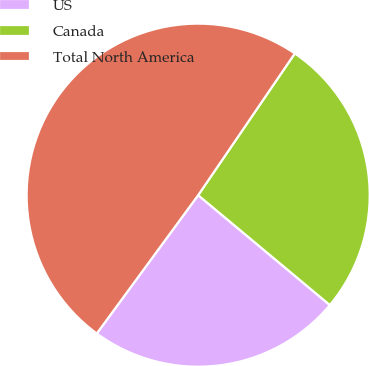Convert chart to OTSL. <chart><loc_0><loc_0><loc_500><loc_500><pie_chart><fcel>US<fcel>Canada<fcel>Total North America<nl><fcel>24.0%<fcel>26.54%<fcel>49.46%<nl></chart> 